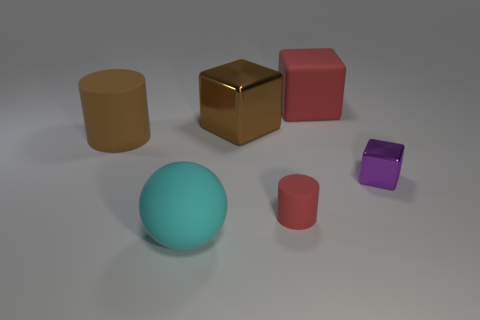Add 3 large brown cylinders. How many objects exist? 9 Subtract all cylinders. How many objects are left? 4 Subtract 0 yellow cylinders. How many objects are left? 6 Subtract all tiny green metallic cylinders. Subtract all small red cylinders. How many objects are left? 5 Add 2 red matte cubes. How many red matte cubes are left? 3 Add 5 tiny purple balls. How many tiny purple balls exist? 5 